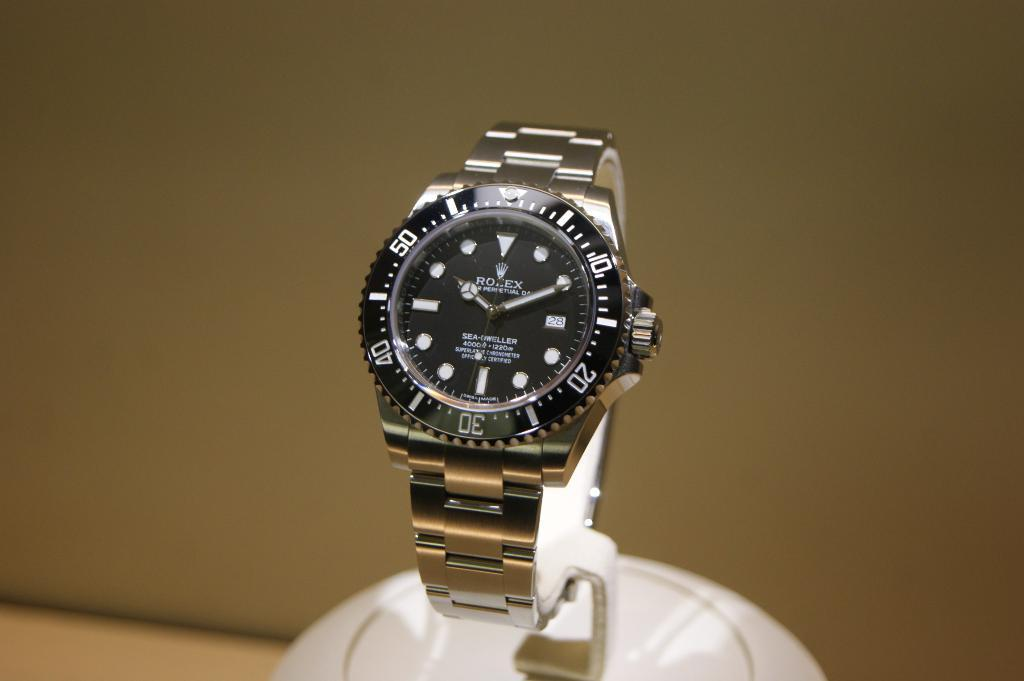<image>
Write a terse but informative summary of the picture. A Rolex watch has a gold band and white numbers. 